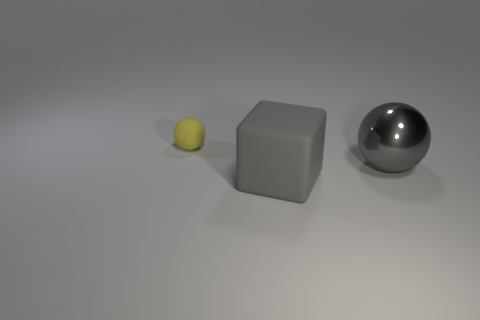Add 3 small balls. How many objects exist? 6 Subtract all blocks. How many objects are left? 2 Add 3 large cubes. How many large cubes are left? 4 Add 1 large gray spheres. How many large gray spheres exist? 2 Subtract 0 blue cylinders. How many objects are left? 3 Subtract all purple spheres. Subtract all blue cylinders. How many spheres are left? 2 Subtract all purple matte blocks. Subtract all yellow matte objects. How many objects are left? 2 